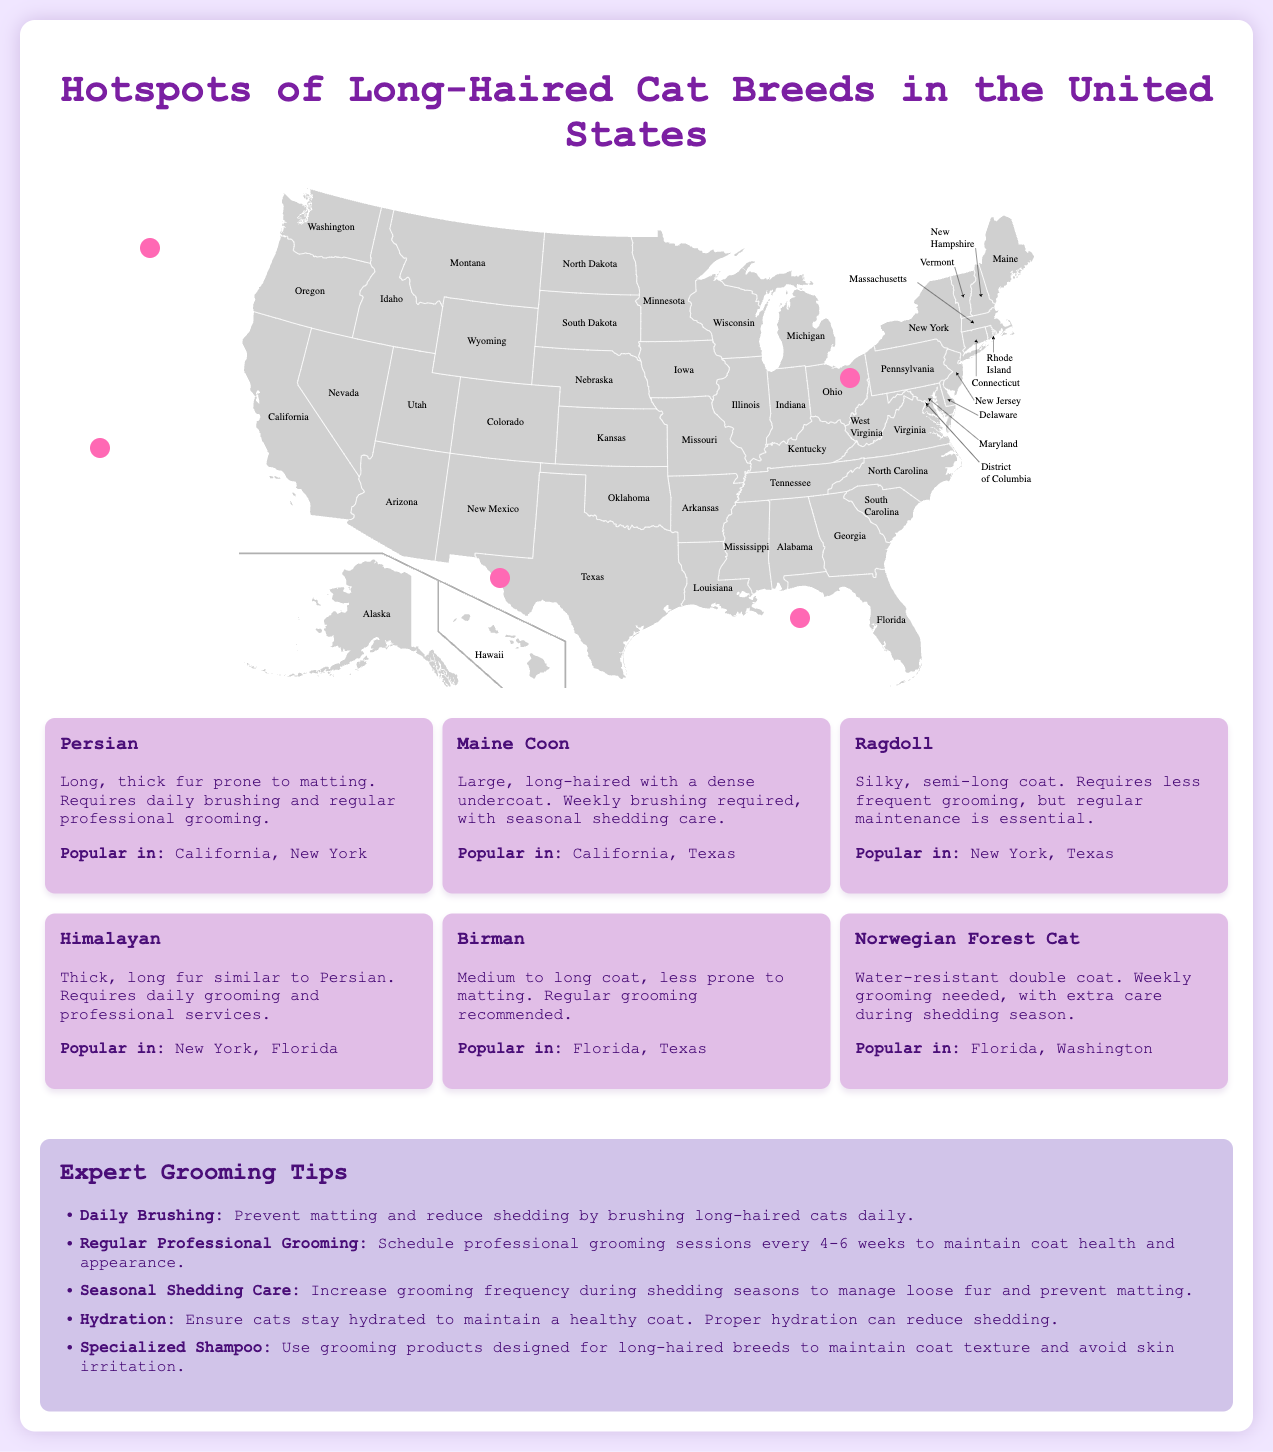What are the popular long-haired cat breeds in California? The document lists Persian and Maine Coon as popular breeds in California.
Answer: Persian, Maine Coon Which breed requires daily brushing? The Persian breed is noted for needing daily brushing due to its long, thick fur.
Answer: Persian What is the grooming need for Maine Coons? The document states that Maine Coons require weekly brushing with seasonal shedding care.
Answer: Weekly brushing Which state has a growing interest in long-haired breeds? Texas is identified as having a growing interest in long-haired cat breeds.
Answer: Texas What is the population characteristic highlighted for New York? New York is described as having a high-end grooming service trend for long-haired breeds.
Answer: High What common grooming advice is given for long-haired cats? The document advises daily brushing to prevent matting and reduce shedding.
Answer: Daily brushing In which state is the Norwegian Forest Cat mentioned? The Norwegian Forest Cat is mentioned as popular in Florida and Washington.
Answer: Florida, Washington What color is the background of the infographic? The infographic has a background color of light purple (#f0e6ff).
Answer: Light purple What is a specified grooming frequency for Ragdolls? The document states that Ragdolls require regular maintenance but less frequent grooming.
Answer: Less frequent How many hotspots are indicated on the map? The document suggests five distinct regions highlighted as hotspots for long-haired cat breeds.
Answer: Five 